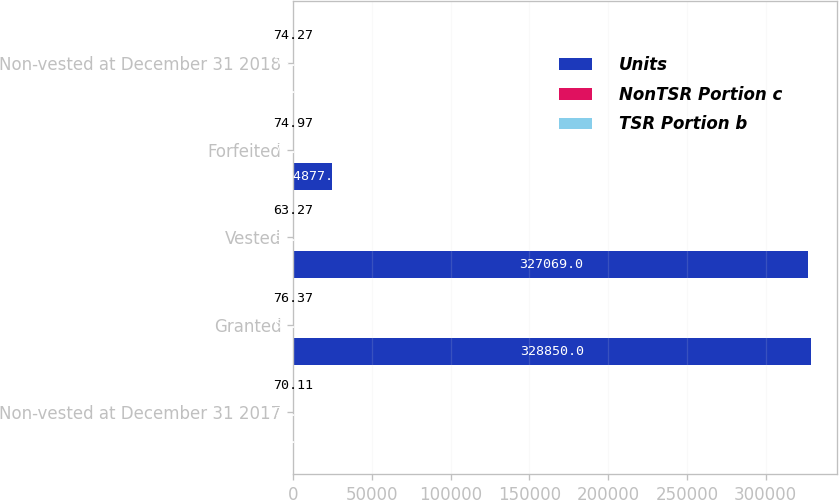Convert chart. <chart><loc_0><loc_0><loc_500><loc_500><stacked_bar_chart><ecel><fcel>Non-vested at December 31 2017<fcel>Granted<fcel>Vested<fcel>Forfeited<fcel>Non-vested at December 31 2018<nl><fcel>Units<fcel>74.27<fcel>328850<fcel>327069<fcel>24877<fcel>74.27<nl><fcel>NonTSR Portion c<fcel>71.74<fcel>67.26<fcel>57.77<fcel>72.22<fcel>74.81<nl><fcel>TSR Portion b<fcel>70.11<fcel>76.37<fcel>63.27<fcel>74.97<fcel>74.27<nl></chart> 